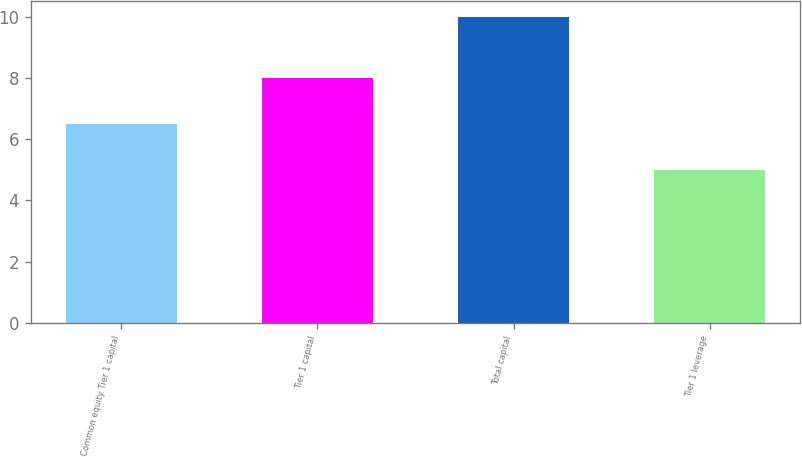Convert chart. <chart><loc_0><loc_0><loc_500><loc_500><bar_chart><fcel>Common equity Tier 1 capital<fcel>Tier 1 capital<fcel>Total capital<fcel>Tier 1 leverage<nl><fcel>6.5<fcel>8<fcel>10<fcel>5<nl></chart> 